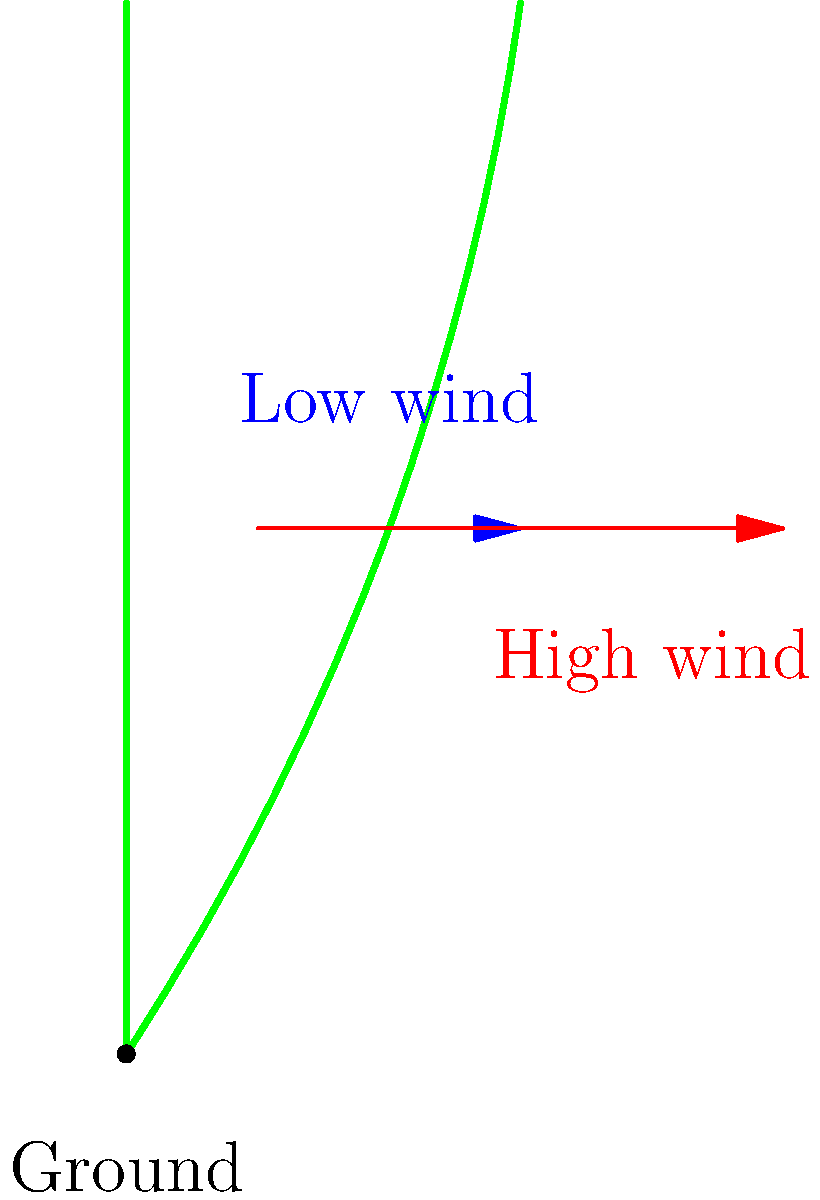Based on the diagram, which biomechanical principle best explains the difference in stem curvature between the two wind conditions, and how does this affect the plant's ability to capture sunlight? To answer this question, we need to consider the biomechanical forces acting on the plant stems:

1. In low wind conditions (blue arrow):
   - The stem remains relatively straight.
   - There's minimal bending force applied to the stem.

2. In high wind conditions (red arrow):
   - The stem shows significant curvature.
   - There's a considerable bending force applied to the stem.

3. Biomechanical principle: Thigmomorphogenesis
   - Plants respond to mechanical stress (like wind) by altering their growth patterns.
   - This response helps plants withstand environmental stresses.

4. Stem curvature and wind force:
   - As wind speed increases, the bending moment ($$M = F \times d$$) on the stem increases.
   - The stem bends to reduce the effective force by decreasing its cross-sectional area perpendicular to the wind.

5. Adaptation benefits:
   - Reduces the risk of stem breakage in high winds.
   - Allows the plant to be more flexible and resilient.

6. Effect on sunlight capture:
   - In low wind: Straight stem maximizes vertical growth and sunlight exposure.
   - In high wind: Curved stem may reduce overall height but increases stability.
   - The plant may compensate by adjusting leaf angles or developing a more spread-out canopy.

The principle of thigmomorphogenesis explains the observed difference in stem curvature and represents an adaptive response that balances the need for sunlight capture with structural integrity in varying wind conditions.
Answer: Thigmomorphogenesis; balances sunlight capture and structural integrity 